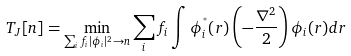<formula> <loc_0><loc_0><loc_500><loc_500>T _ { J } [ n ] = \min _ { \sum _ { i } f _ { i } | \phi _ { i } | ^ { 2 } \rightarrow n } \sum _ { i } f _ { i } \int { \phi } ^ { ^ { * } } _ { i } ( { r } ) \left ( - \frac { \nabla ^ { 2 } } { 2 } \right ) \phi _ { i } ( { r } ) d { r }</formula> 